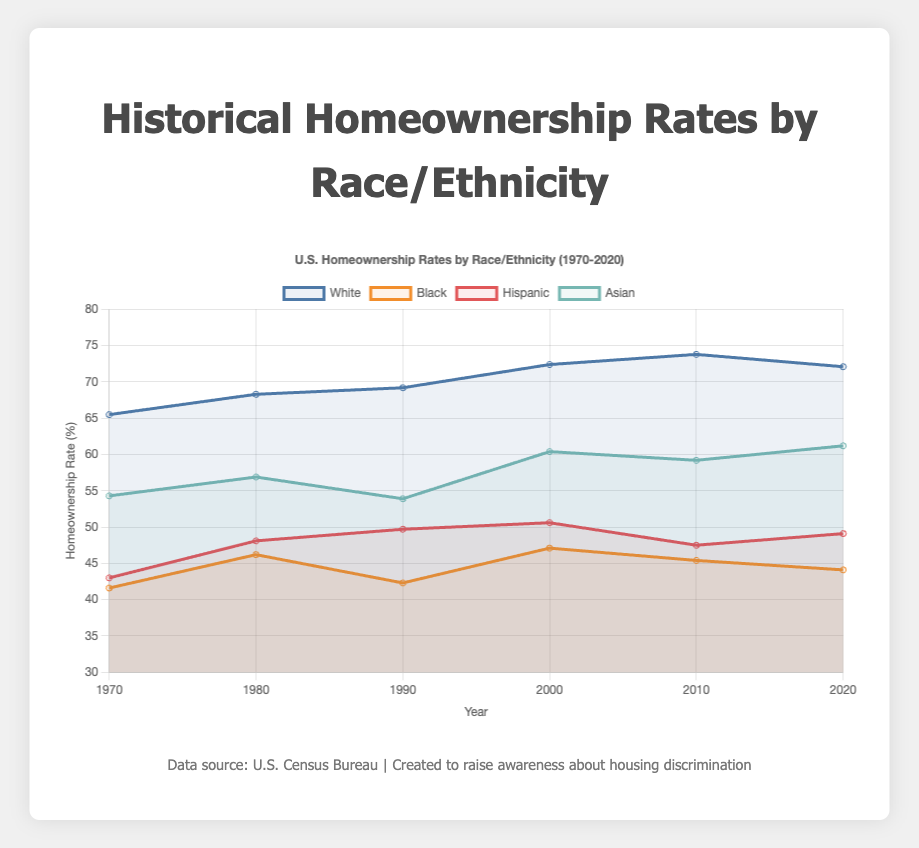Which racial or ethnic group consistently has the highest homeownership rate over the years? By observing the line plot, the line representing the "White" group is consistently the highest across all years from 1970 to 2020.
Answer: White In which decade did the Black homeownership rate see its highest peak? Referring to the line for the Black group, the highest peak occurred around the decade of 2000.
Answer: 2000 Compare the homeownership rates of the Hispanic and Black groups in the year 2020. Which is higher? Checking the endpoints of the lines for Hispanic and Black groups in 2020, the line for Hispanic is higher than that of Black.
Answer: Hispanic What was the percentage increase in the Asian homeownership rate from 1970 to 2020? The Asian homeownership rate in 1970 was 54.3%, and in 2020 it was 61.2%. The percentage increase is (61.2 - 54.3)/54.3 * 100.
Answer: 12.7% Which group's homeownership rate decreased the most from its peak to 2020? The Black group's peak was 47.1% in 2000 and decreased to 44.1% in 2020, a decrease of 3 percentage points. The White group's peak was 73.8% in 2010 and decreased to 72.1% in 2020, a decrease of 1.7 percentage points. Thus, the largest decrease is in the Black group.
Answer: Black What is the difference between the White and Hispanic homeownership rates in 2010? The White homeownership rate in 2010 was 73.8%, and the Hispanic rate was 47.5%. The difference is 73.8 - 47.5 = 26.3 percentage points.
Answer: 26.3 Which group showed a continuous increase in homeownership rates from 1990 to 2020? By analyzing the slope of lines, the Hispanic and Asian groups both show an overall increase, but only the Hispanic group shows a continuous increase without any drop between 1990 and 2020.
Answer: Hispanic What was the average homeownership rate of the Black group over the decades provided? The Black homeownership rates are [41.6, 46.2, 42.3, 47.1, 45.4, 44.1]. The average is (41.6 + 46.2 + 42.3 + 47.1 + 45.4 + 44.1) / 6.
Answer: 44.45% How did the homeownership rate for White people change from 1980 to 2010? The rate in 1980 was 68.3% and in 2010 it was 73.8%. The change is 73.8 - 68.3 = 5.5 percentage points increase.
Answer: 5.5 